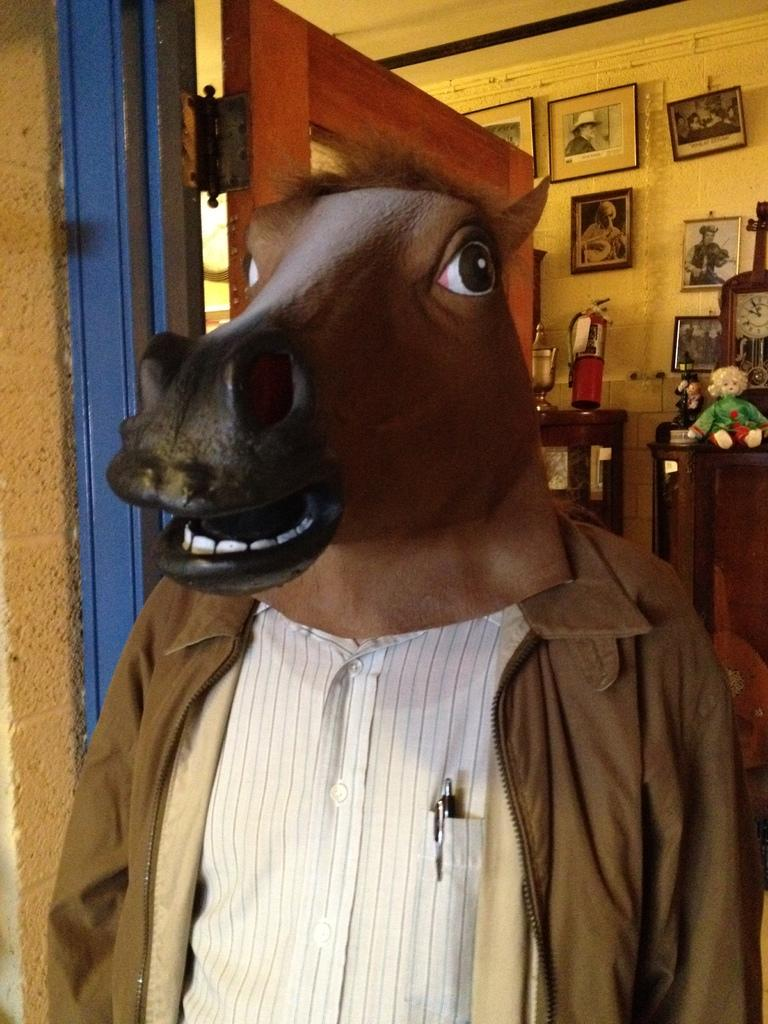What is the person in the image wearing on their face? The person in the image is wearing a mask. What can be seen in the background of the image? There is a door, photo frames, and a doll in the background of the image. What type of eggnog is being served in the image? There is no eggnog present in the image. What genre of fiction is being read by the person in the image? There is no book or any indication of reading in the image. 